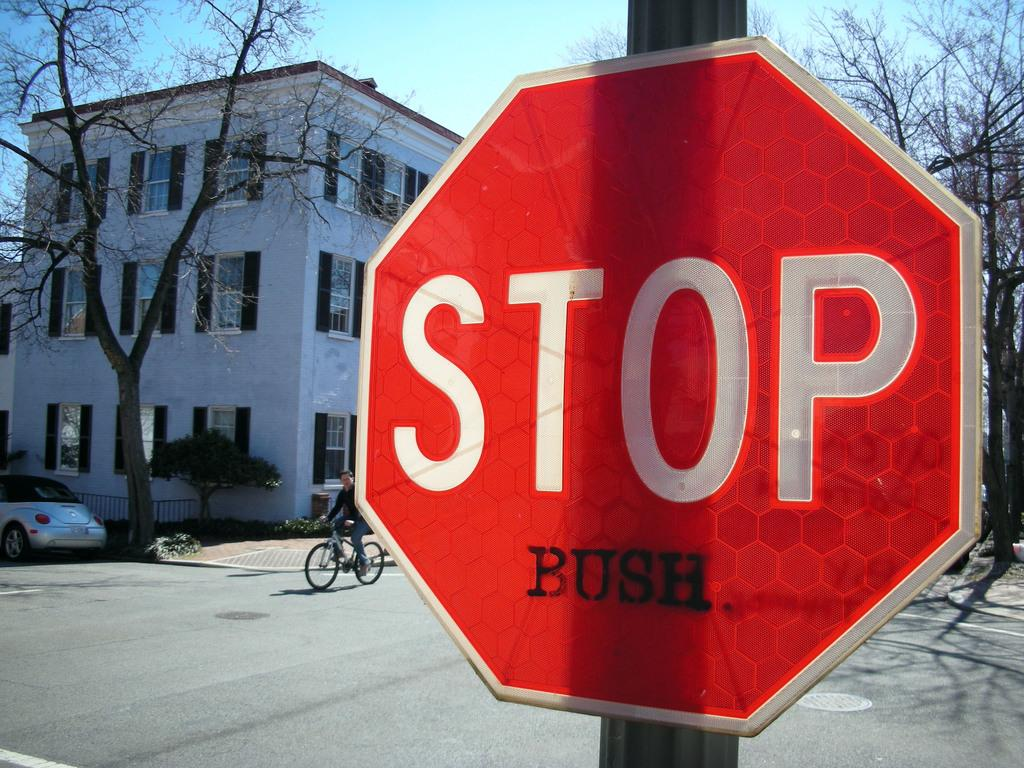<image>
Give a short and clear explanation of the subsequent image. A red STOP sigb sits on a street and has BUSH painted on the bottom of it. 